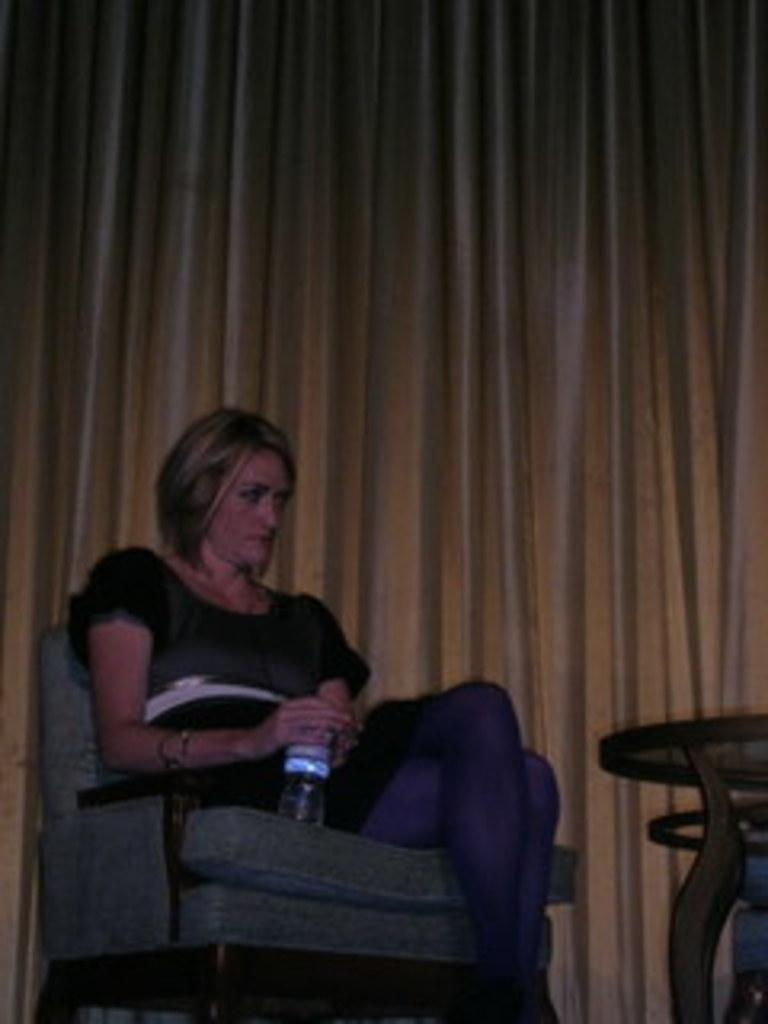Who is the main subject in the image? There is a woman in the image. What is the woman doing in the image? The woman is sitting on a chair. What object is the woman holding in her hand? The woman is holding a water bottle in her hand. Can you see any cream on the lake near the gate in the image? There is no lake, gate, or cream present in the image. 